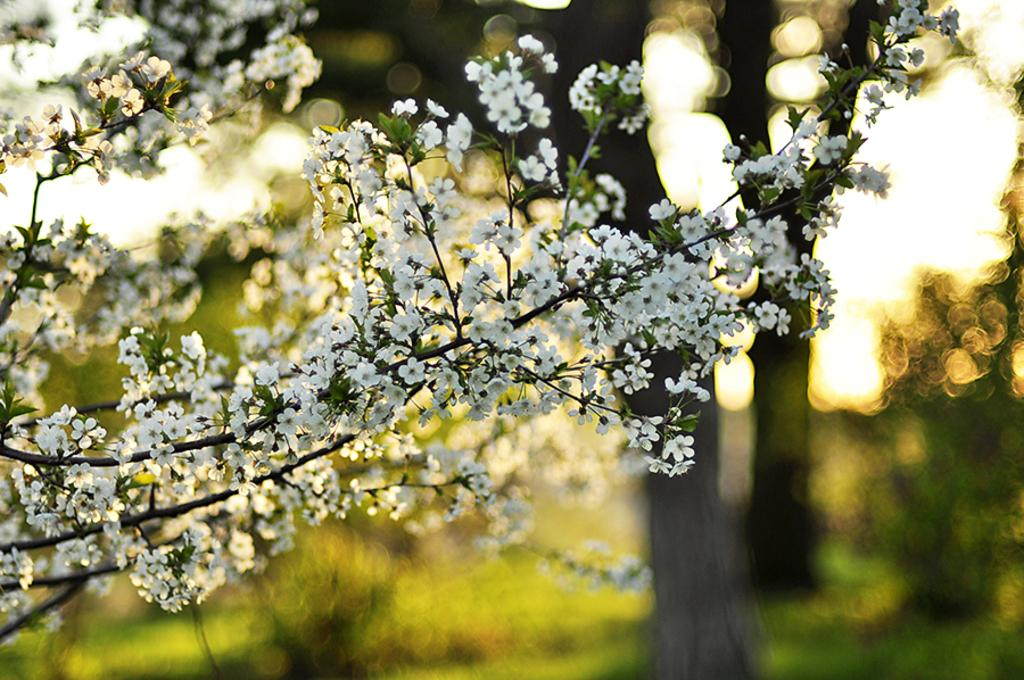What type of plant is visible in the image? There is a plant with flowers in the image. Can you describe the background of the image? The background of the image is blurred. How many apples can be seen hanging from the plant in the image? There are no apples present on the plant in the image. What type of activity is the plant engaging in the image? Plants do not engage in activities like sleeping or walking. 